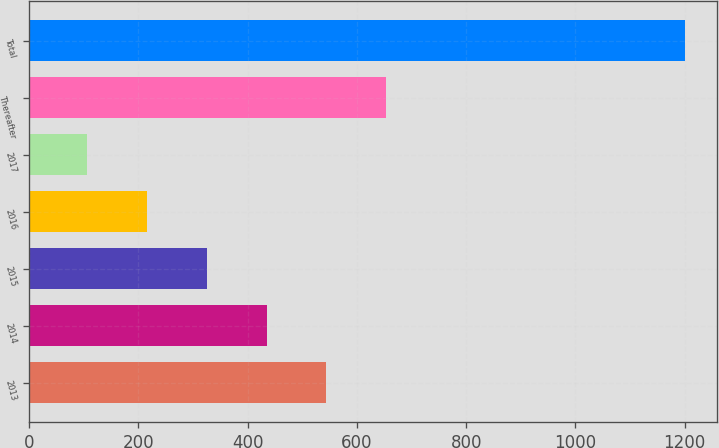<chart> <loc_0><loc_0><loc_500><loc_500><bar_chart><fcel>2013<fcel>2014<fcel>2015<fcel>2016<fcel>2017<fcel>Thereafter<fcel>Total<nl><fcel>544.2<fcel>434.9<fcel>325.6<fcel>216.3<fcel>107<fcel>653.5<fcel>1200<nl></chart> 